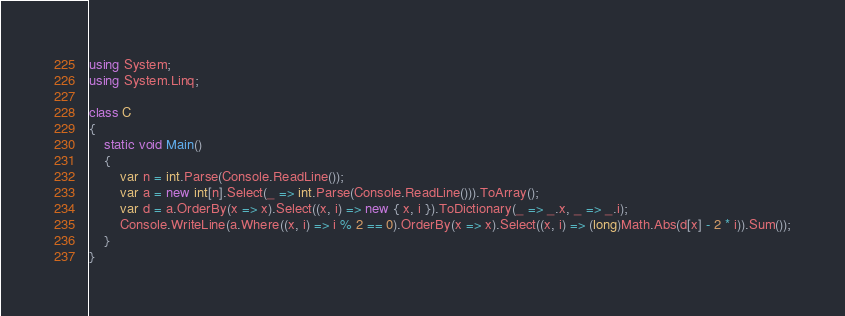Convert code to text. <code><loc_0><loc_0><loc_500><loc_500><_C#_>using System;
using System.Linq;

class C
{
	static void Main()
	{
		var n = int.Parse(Console.ReadLine());
		var a = new int[n].Select(_ => int.Parse(Console.ReadLine())).ToArray();
		var d = a.OrderBy(x => x).Select((x, i) => new { x, i }).ToDictionary(_ => _.x, _ => _.i);
		Console.WriteLine(a.Where((x, i) => i % 2 == 0).OrderBy(x => x).Select((x, i) => (long)Math.Abs(d[x] - 2 * i)).Sum());
	}
}
</code> 